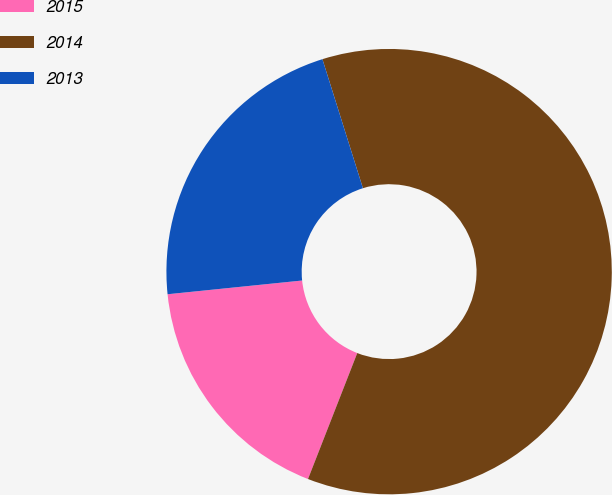Convert chart to OTSL. <chart><loc_0><loc_0><loc_500><loc_500><pie_chart><fcel>2015<fcel>2014<fcel>2013<nl><fcel>17.45%<fcel>60.78%<fcel>21.78%<nl></chart> 